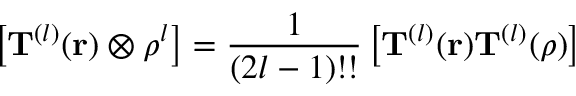Convert formula to latex. <formula><loc_0><loc_0><loc_500><loc_500>\left [ T ^ { ( l ) } ( r ) \otimes { \rho } ^ { l } \right ] = { \frac { 1 } { ( 2 l - 1 ) ! ! } } \left [ T ^ { ( l ) } ( r ) T ^ { ( l ) } ( { \rho } ) \right ]</formula> 